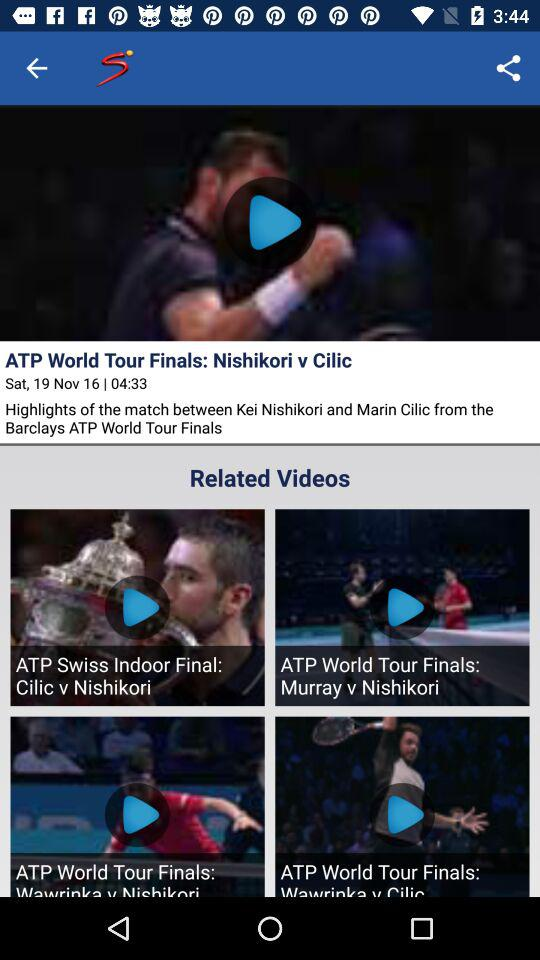What is the broadcast date and time of the ATP World Tour Finals? The date is Saturday, November 16, and the time is 04:33. 